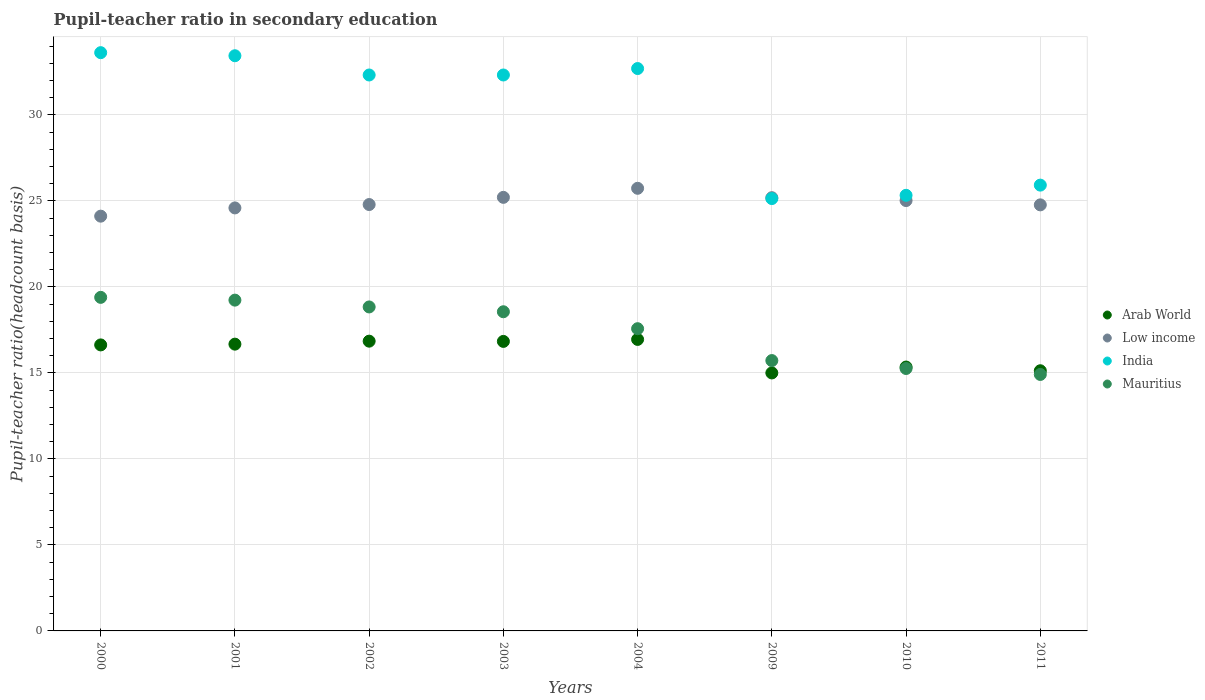How many different coloured dotlines are there?
Keep it short and to the point. 4. Is the number of dotlines equal to the number of legend labels?
Your answer should be compact. Yes. What is the pupil-teacher ratio in secondary education in Arab World in 2009?
Give a very brief answer. 15. Across all years, what is the maximum pupil-teacher ratio in secondary education in Arab World?
Ensure brevity in your answer.  16.95. Across all years, what is the minimum pupil-teacher ratio in secondary education in Mauritius?
Offer a terse response. 14.91. In which year was the pupil-teacher ratio in secondary education in India maximum?
Keep it short and to the point. 2000. In which year was the pupil-teacher ratio in secondary education in Arab World minimum?
Provide a short and direct response. 2009. What is the total pupil-teacher ratio in secondary education in Mauritius in the graph?
Ensure brevity in your answer.  139.49. What is the difference between the pupil-teacher ratio in secondary education in Arab World in 2000 and that in 2001?
Offer a terse response. -0.04. What is the difference between the pupil-teacher ratio in secondary education in Mauritius in 2004 and the pupil-teacher ratio in secondary education in India in 2002?
Make the answer very short. -14.75. What is the average pupil-teacher ratio in secondary education in Mauritius per year?
Make the answer very short. 17.44. In the year 2009, what is the difference between the pupil-teacher ratio in secondary education in Low income and pupil-teacher ratio in secondary education in Arab World?
Your response must be concise. 10.19. In how many years, is the pupil-teacher ratio in secondary education in India greater than 29?
Your answer should be very brief. 5. What is the ratio of the pupil-teacher ratio in secondary education in Mauritius in 2009 to that in 2011?
Make the answer very short. 1.05. Is the difference between the pupil-teacher ratio in secondary education in Low income in 2002 and 2003 greater than the difference between the pupil-teacher ratio in secondary education in Arab World in 2002 and 2003?
Your answer should be very brief. No. What is the difference between the highest and the second highest pupil-teacher ratio in secondary education in Mauritius?
Your response must be concise. 0.16. What is the difference between the highest and the lowest pupil-teacher ratio in secondary education in Mauritius?
Ensure brevity in your answer.  4.48. In how many years, is the pupil-teacher ratio in secondary education in Arab World greater than the average pupil-teacher ratio in secondary education in Arab World taken over all years?
Your answer should be very brief. 5. Is the sum of the pupil-teacher ratio in secondary education in Arab World in 2001 and 2002 greater than the maximum pupil-teacher ratio in secondary education in India across all years?
Your answer should be compact. No. Is it the case that in every year, the sum of the pupil-teacher ratio in secondary education in Mauritius and pupil-teacher ratio in secondary education in Arab World  is greater than the sum of pupil-teacher ratio in secondary education in India and pupil-teacher ratio in secondary education in Low income?
Keep it short and to the point. No. Does the pupil-teacher ratio in secondary education in India monotonically increase over the years?
Your response must be concise. No. Is the pupil-teacher ratio in secondary education in India strictly greater than the pupil-teacher ratio in secondary education in Mauritius over the years?
Ensure brevity in your answer.  Yes. Is the pupil-teacher ratio in secondary education in Mauritius strictly less than the pupil-teacher ratio in secondary education in India over the years?
Provide a short and direct response. Yes. How many years are there in the graph?
Provide a succinct answer. 8. What is the difference between two consecutive major ticks on the Y-axis?
Ensure brevity in your answer.  5. Where does the legend appear in the graph?
Your response must be concise. Center right. How are the legend labels stacked?
Offer a very short reply. Vertical. What is the title of the graph?
Keep it short and to the point. Pupil-teacher ratio in secondary education. Does "Cyprus" appear as one of the legend labels in the graph?
Provide a short and direct response. No. What is the label or title of the X-axis?
Provide a short and direct response. Years. What is the label or title of the Y-axis?
Provide a succinct answer. Pupil-teacher ratio(headcount basis). What is the Pupil-teacher ratio(headcount basis) in Arab World in 2000?
Ensure brevity in your answer.  16.63. What is the Pupil-teacher ratio(headcount basis) of Low income in 2000?
Your answer should be very brief. 24.12. What is the Pupil-teacher ratio(headcount basis) in India in 2000?
Keep it short and to the point. 33.62. What is the Pupil-teacher ratio(headcount basis) in Mauritius in 2000?
Make the answer very short. 19.4. What is the Pupil-teacher ratio(headcount basis) of Arab World in 2001?
Provide a short and direct response. 16.67. What is the Pupil-teacher ratio(headcount basis) of Low income in 2001?
Provide a short and direct response. 24.6. What is the Pupil-teacher ratio(headcount basis) of India in 2001?
Offer a terse response. 33.44. What is the Pupil-teacher ratio(headcount basis) in Mauritius in 2001?
Ensure brevity in your answer.  19.23. What is the Pupil-teacher ratio(headcount basis) in Arab World in 2002?
Your answer should be very brief. 16.85. What is the Pupil-teacher ratio(headcount basis) in Low income in 2002?
Provide a short and direct response. 24.79. What is the Pupil-teacher ratio(headcount basis) of India in 2002?
Your response must be concise. 32.32. What is the Pupil-teacher ratio(headcount basis) of Mauritius in 2002?
Provide a short and direct response. 18.84. What is the Pupil-teacher ratio(headcount basis) of Arab World in 2003?
Ensure brevity in your answer.  16.83. What is the Pupil-teacher ratio(headcount basis) of Low income in 2003?
Offer a terse response. 25.21. What is the Pupil-teacher ratio(headcount basis) of India in 2003?
Your response must be concise. 32.32. What is the Pupil-teacher ratio(headcount basis) in Mauritius in 2003?
Offer a very short reply. 18.56. What is the Pupil-teacher ratio(headcount basis) in Arab World in 2004?
Provide a short and direct response. 16.95. What is the Pupil-teacher ratio(headcount basis) in Low income in 2004?
Provide a succinct answer. 25.74. What is the Pupil-teacher ratio(headcount basis) in India in 2004?
Your answer should be compact. 32.7. What is the Pupil-teacher ratio(headcount basis) in Mauritius in 2004?
Offer a very short reply. 17.57. What is the Pupil-teacher ratio(headcount basis) in Arab World in 2009?
Offer a very short reply. 15. What is the Pupil-teacher ratio(headcount basis) of Low income in 2009?
Provide a short and direct response. 25.19. What is the Pupil-teacher ratio(headcount basis) of India in 2009?
Provide a succinct answer. 25.14. What is the Pupil-teacher ratio(headcount basis) in Mauritius in 2009?
Keep it short and to the point. 15.72. What is the Pupil-teacher ratio(headcount basis) of Arab World in 2010?
Give a very brief answer. 15.34. What is the Pupil-teacher ratio(headcount basis) of Low income in 2010?
Your response must be concise. 25.02. What is the Pupil-teacher ratio(headcount basis) in India in 2010?
Offer a very short reply. 25.33. What is the Pupil-teacher ratio(headcount basis) in Mauritius in 2010?
Keep it short and to the point. 15.26. What is the Pupil-teacher ratio(headcount basis) of Arab World in 2011?
Your response must be concise. 15.13. What is the Pupil-teacher ratio(headcount basis) of Low income in 2011?
Give a very brief answer. 24.77. What is the Pupil-teacher ratio(headcount basis) of India in 2011?
Give a very brief answer. 25.92. What is the Pupil-teacher ratio(headcount basis) in Mauritius in 2011?
Provide a succinct answer. 14.91. Across all years, what is the maximum Pupil-teacher ratio(headcount basis) of Arab World?
Give a very brief answer. 16.95. Across all years, what is the maximum Pupil-teacher ratio(headcount basis) of Low income?
Offer a terse response. 25.74. Across all years, what is the maximum Pupil-teacher ratio(headcount basis) in India?
Provide a succinct answer. 33.62. Across all years, what is the maximum Pupil-teacher ratio(headcount basis) in Mauritius?
Ensure brevity in your answer.  19.4. Across all years, what is the minimum Pupil-teacher ratio(headcount basis) of Arab World?
Give a very brief answer. 15. Across all years, what is the minimum Pupil-teacher ratio(headcount basis) of Low income?
Provide a short and direct response. 24.12. Across all years, what is the minimum Pupil-teacher ratio(headcount basis) of India?
Offer a terse response. 25.14. Across all years, what is the minimum Pupil-teacher ratio(headcount basis) in Mauritius?
Your answer should be very brief. 14.91. What is the total Pupil-teacher ratio(headcount basis) of Arab World in the graph?
Provide a succinct answer. 129.41. What is the total Pupil-teacher ratio(headcount basis) of Low income in the graph?
Offer a very short reply. 199.44. What is the total Pupil-teacher ratio(headcount basis) of India in the graph?
Ensure brevity in your answer.  240.81. What is the total Pupil-teacher ratio(headcount basis) in Mauritius in the graph?
Keep it short and to the point. 139.49. What is the difference between the Pupil-teacher ratio(headcount basis) in Arab World in 2000 and that in 2001?
Ensure brevity in your answer.  -0.04. What is the difference between the Pupil-teacher ratio(headcount basis) in Low income in 2000 and that in 2001?
Give a very brief answer. -0.48. What is the difference between the Pupil-teacher ratio(headcount basis) in India in 2000 and that in 2001?
Your answer should be compact. 0.18. What is the difference between the Pupil-teacher ratio(headcount basis) of Mauritius in 2000 and that in 2001?
Your answer should be compact. 0.16. What is the difference between the Pupil-teacher ratio(headcount basis) of Arab World in 2000 and that in 2002?
Give a very brief answer. -0.22. What is the difference between the Pupil-teacher ratio(headcount basis) of Low income in 2000 and that in 2002?
Ensure brevity in your answer.  -0.68. What is the difference between the Pupil-teacher ratio(headcount basis) in India in 2000 and that in 2002?
Make the answer very short. 1.3. What is the difference between the Pupil-teacher ratio(headcount basis) in Mauritius in 2000 and that in 2002?
Ensure brevity in your answer.  0.56. What is the difference between the Pupil-teacher ratio(headcount basis) in Arab World in 2000 and that in 2003?
Keep it short and to the point. -0.2. What is the difference between the Pupil-teacher ratio(headcount basis) of Low income in 2000 and that in 2003?
Your answer should be very brief. -1.09. What is the difference between the Pupil-teacher ratio(headcount basis) in India in 2000 and that in 2003?
Your answer should be very brief. 1.3. What is the difference between the Pupil-teacher ratio(headcount basis) in Mauritius in 2000 and that in 2003?
Offer a very short reply. 0.84. What is the difference between the Pupil-teacher ratio(headcount basis) of Arab World in 2000 and that in 2004?
Provide a short and direct response. -0.32. What is the difference between the Pupil-teacher ratio(headcount basis) in Low income in 2000 and that in 2004?
Your answer should be compact. -1.62. What is the difference between the Pupil-teacher ratio(headcount basis) in India in 2000 and that in 2004?
Keep it short and to the point. 0.92. What is the difference between the Pupil-teacher ratio(headcount basis) in Mauritius in 2000 and that in 2004?
Provide a short and direct response. 1.82. What is the difference between the Pupil-teacher ratio(headcount basis) of Arab World in 2000 and that in 2009?
Ensure brevity in your answer.  1.63. What is the difference between the Pupil-teacher ratio(headcount basis) of Low income in 2000 and that in 2009?
Your response must be concise. -1.07. What is the difference between the Pupil-teacher ratio(headcount basis) in India in 2000 and that in 2009?
Your response must be concise. 8.48. What is the difference between the Pupil-teacher ratio(headcount basis) in Mauritius in 2000 and that in 2009?
Provide a short and direct response. 3.68. What is the difference between the Pupil-teacher ratio(headcount basis) in Arab World in 2000 and that in 2010?
Provide a succinct answer. 1.29. What is the difference between the Pupil-teacher ratio(headcount basis) of Low income in 2000 and that in 2010?
Ensure brevity in your answer.  -0.91. What is the difference between the Pupil-teacher ratio(headcount basis) in India in 2000 and that in 2010?
Offer a terse response. 8.29. What is the difference between the Pupil-teacher ratio(headcount basis) in Mauritius in 2000 and that in 2010?
Your response must be concise. 4.14. What is the difference between the Pupil-teacher ratio(headcount basis) in Arab World in 2000 and that in 2011?
Provide a short and direct response. 1.5. What is the difference between the Pupil-teacher ratio(headcount basis) in Low income in 2000 and that in 2011?
Offer a very short reply. -0.66. What is the difference between the Pupil-teacher ratio(headcount basis) of India in 2000 and that in 2011?
Make the answer very short. 7.7. What is the difference between the Pupil-teacher ratio(headcount basis) in Mauritius in 2000 and that in 2011?
Make the answer very short. 4.48. What is the difference between the Pupil-teacher ratio(headcount basis) of Arab World in 2001 and that in 2002?
Keep it short and to the point. -0.17. What is the difference between the Pupil-teacher ratio(headcount basis) of Low income in 2001 and that in 2002?
Provide a short and direct response. -0.2. What is the difference between the Pupil-teacher ratio(headcount basis) in India in 2001 and that in 2002?
Make the answer very short. 1.12. What is the difference between the Pupil-teacher ratio(headcount basis) in Mauritius in 2001 and that in 2002?
Make the answer very short. 0.4. What is the difference between the Pupil-teacher ratio(headcount basis) of Arab World in 2001 and that in 2003?
Keep it short and to the point. -0.16. What is the difference between the Pupil-teacher ratio(headcount basis) of Low income in 2001 and that in 2003?
Your response must be concise. -0.61. What is the difference between the Pupil-teacher ratio(headcount basis) of India in 2001 and that in 2003?
Provide a succinct answer. 1.12. What is the difference between the Pupil-teacher ratio(headcount basis) of Mauritius in 2001 and that in 2003?
Provide a succinct answer. 0.68. What is the difference between the Pupil-teacher ratio(headcount basis) in Arab World in 2001 and that in 2004?
Your response must be concise. -0.27. What is the difference between the Pupil-teacher ratio(headcount basis) in Low income in 2001 and that in 2004?
Your response must be concise. -1.14. What is the difference between the Pupil-teacher ratio(headcount basis) of India in 2001 and that in 2004?
Ensure brevity in your answer.  0.74. What is the difference between the Pupil-teacher ratio(headcount basis) of Mauritius in 2001 and that in 2004?
Offer a very short reply. 1.66. What is the difference between the Pupil-teacher ratio(headcount basis) in Arab World in 2001 and that in 2009?
Make the answer very short. 1.67. What is the difference between the Pupil-teacher ratio(headcount basis) of Low income in 2001 and that in 2009?
Make the answer very short. -0.59. What is the difference between the Pupil-teacher ratio(headcount basis) of India in 2001 and that in 2009?
Your answer should be very brief. 8.31. What is the difference between the Pupil-teacher ratio(headcount basis) of Mauritius in 2001 and that in 2009?
Offer a terse response. 3.51. What is the difference between the Pupil-teacher ratio(headcount basis) of Arab World in 2001 and that in 2010?
Ensure brevity in your answer.  1.33. What is the difference between the Pupil-teacher ratio(headcount basis) of Low income in 2001 and that in 2010?
Make the answer very short. -0.43. What is the difference between the Pupil-teacher ratio(headcount basis) of India in 2001 and that in 2010?
Ensure brevity in your answer.  8.12. What is the difference between the Pupil-teacher ratio(headcount basis) in Mauritius in 2001 and that in 2010?
Keep it short and to the point. 3.98. What is the difference between the Pupil-teacher ratio(headcount basis) in Arab World in 2001 and that in 2011?
Provide a short and direct response. 1.55. What is the difference between the Pupil-teacher ratio(headcount basis) of Low income in 2001 and that in 2011?
Your response must be concise. -0.18. What is the difference between the Pupil-teacher ratio(headcount basis) of India in 2001 and that in 2011?
Make the answer very short. 7.52. What is the difference between the Pupil-teacher ratio(headcount basis) of Mauritius in 2001 and that in 2011?
Your answer should be compact. 4.32. What is the difference between the Pupil-teacher ratio(headcount basis) in Arab World in 2002 and that in 2003?
Offer a terse response. 0.01. What is the difference between the Pupil-teacher ratio(headcount basis) of Low income in 2002 and that in 2003?
Offer a very short reply. -0.42. What is the difference between the Pupil-teacher ratio(headcount basis) of India in 2002 and that in 2003?
Your answer should be compact. -0. What is the difference between the Pupil-teacher ratio(headcount basis) of Mauritius in 2002 and that in 2003?
Your answer should be very brief. 0.28. What is the difference between the Pupil-teacher ratio(headcount basis) of Arab World in 2002 and that in 2004?
Offer a very short reply. -0.1. What is the difference between the Pupil-teacher ratio(headcount basis) of Low income in 2002 and that in 2004?
Provide a short and direct response. -0.94. What is the difference between the Pupil-teacher ratio(headcount basis) of India in 2002 and that in 2004?
Your answer should be very brief. -0.38. What is the difference between the Pupil-teacher ratio(headcount basis) in Mauritius in 2002 and that in 2004?
Make the answer very short. 1.26. What is the difference between the Pupil-teacher ratio(headcount basis) of Arab World in 2002 and that in 2009?
Make the answer very short. 1.85. What is the difference between the Pupil-teacher ratio(headcount basis) in Low income in 2002 and that in 2009?
Provide a short and direct response. -0.4. What is the difference between the Pupil-teacher ratio(headcount basis) in India in 2002 and that in 2009?
Offer a terse response. 7.19. What is the difference between the Pupil-teacher ratio(headcount basis) of Mauritius in 2002 and that in 2009?
Your response must be concise. 3.12. What is the difference between the Pupil-teacher ratio(headcount basis) in Arab World in 2002 and that in 2010?
Your answer should be compact. 1.51. What is the difference between the Pupil-teacher ratio(headcount basis) of Low income in 2002 and that in 2010?
Make the answer very short. -0.23. What is the difference between the Pupil-teacher ratio(headcount basis) in India in 2002 and that in 2010?
Make the answer very short. 7. What is the difference between the Pupil-teacher ratio(headcount basis) of Mauritius in 2002 and that in 2010?
Offer a terse response. 3.58. What is the difference between the Pupil-teacher ratio(headcount basis) in Arab World in 2002 and that in 2011?
Offer a terse response. 1.72. What is the difference between the Pupil-teacher ratio(headcount basis) in Low income in 2002 and that in 2011?
Give a very brief answer. 0.02. What is the difference between the Pupil-teacher ratio(headcount basis) of India in 2002 and that in 2011?
Keep it short and to the point. 6.4. What is the difference between the Pupil-teacher ratio(headcount basis) of Mauritius in 2002 and that in 2011?
Make the answer very short. 3.93. What is the difference between the Pupil-teacher ratio(headcount basis) in Arab World in 2003 and that in 2004?
Your answer should be compact. -0.12. What is the difference between the Pupil-teacher ratio(headcount basis) of Low income in 2003 and that in 2004?
Your response must be concise. -0.53. What is the difference between the Pupil-teacher ratio(headcount basis) of India in 2003 and that in 2004?
Ensure brevity in your answer.  -0.38. What is the difference between the Pupil-teacher ratio(headcount basis) of Mauritius in 2003 and that in 2004?
Your response must be concise. 0.98. What is the difference between the Pupil-teacher ratio(headcount basis) in Arab World in 2003 and that in 2009?
Offer a terse response. 1.83. What is the difference between the Pupil-teacher ratio(headcount basis) of Low income in 2003 and that in 2009?
Your response must be concise. 0.02. What is the difference between the Pupil-teacher ratio(headcount basis) of India in 2003 and that in 2009?
Your response must be concise. 7.19. What is the difference between the Pupil-teacher ratio(headcount basis) of Mauritius in 2003 and that in 2009?
Provide a short and direct response. 2.84. What is the difference between the Pupil-teacher ratio(headcount basis) in Arab World in 2003 and that in 2010?
Provide a short and direct response. 1.49. What is the difference between the Pupil-teacher ratio(headcount basis) of Low income in 2003 and that in 2010?
Your answer should be very brief. 0.19. What is the difference between the Pupil-teacher ratio(headcount basis) in India in 2003 and that in 2010?
Your answer should be very brief. 7. What is the difference between the Pupil-teacher ratio(headcount basis) in Mauritius in 2003 and that in 2010?
Your answer should be very brief. 3.3. What is the difference between the Pupil-teacher ratio(headcount basis) in Arab World in 2003 and that in 2011?
Provide a succinct answer. 1.71. What is the difference between the Pupil-teacher ratio(headcount basis) in Low income in 2003 and that in 2011?
Offer a very short reply. 0.44. What is the difference between the Pupil-teacher ratio(headcount basis) in India in 2003 and that in 2011?
Offer a very short reply. 6.4. What is the difference between the Pupil-teacher ratio(headcount basis) of Mauritius in 2003 and that in 2011?
Provide a succinct answer. 3.65. What is the difference between the Pupil-teacher ratio(headcount basis) in Arab World in 2004 and that in 2009?
Ensure brevity in your answer.  1.95. What is the difference between the Pupil-teacher ratio(headcount basis) of Low income in 2004 and that in 2009?
Keep it short and to the point. 0.55. What is the difference between the Pupil-teacher ratio(headcount basis) in India in 2004 and that in 2009?
Your response must be concise. 7.56. What is the difference between the Pupil-teacher ratio(headcount basis) in Mauritius in 2004 and that in 2009?
Provide a succinct answer. 1.85. What is the difference between the Pupil-teacher ratio(headcount basis) in Arab World in 2004 and that in 2010?
Offer a terse response. 1.61. What is the difference between the Pupil-teacher ratio(headcount basis) of Low income in 2004 and that in 2010?
Keep it short and to the point. 0.71. What is the difference between the Pupil-teacher ratio(headcount basis) in India in 2004 and that in 2010?
Offer a terse response. 7.37. What is the difference between the Pupil-teacher ratio(headcount basis) in Mauritius in 2004 and that in 2010?
Your answer should be very brief. 2.31. What is the difference between the Pupil-teacher ratio(headcount basis) of Arab World in 2004 and that in 2011?
Provide a succinct answer. 1.82. What is the difference between the Pupil-teacher ratio(headcount basis) of Low income in 2004 and that in 2011?
Ensure brevity in your answer.  0.96. What is the difference between the Pupil-teacher ratio(headcount basis) in India in 2004 and that in 2011?
Ensure brevity in your answer.  6.78. What is the difference between the Pupil-teacher ratio(headcount basis) in Mauritius in 2004 and that in 2011?
Your answer should be compact. 2.66. What is the difference between the Pupil-teacher ratio(headcount basis) in Arab World in 2009 and that in 2010?
Give a very brief answer. -0.34. What is the difference between the Pupil-teacher ratio(headcount basis) of Low income in 2009 and that in 2010?
Make the answer very short. 0.17. What is the difference between the Pupil-teacher ratio(headcount basis) of India in 2009 and that in 2010?
Provide a succinct answer. -0.19. What is the difference between the Pupil-teacher ratio(headcount basis) of Mauritius in 2009 and that in 2010?
Your answer should be compact. 0.46. What is the difference between the Pupil-teacher ratio(headcount basis) of Arab World in 2009 and that in 2011?
Provide a succinct answer. -0.13. What is the difference between the Pupil-teacher ratio(headcount basis) of Low income in 2009 and that in 2011?
Make the answer very short. 0.42. What is the difference between the Pupil-teacher ratio(headcount basis) in India in 2009 and that in 2011?
Your answer should be compact. -0.78. What is the difference between the Pupil-teacher ratio(headcount basis) of Mauritius in 2009 and that in 2011?
Provide a succinct answer. 0.81. What is the difference between the Pupil-teacher ratio(headcount basis) in Arab World in 2010 and that in 2011?
Your answer should be compact. 0.21. What is the difference between the Pupil-teacher ratio(headcount basis) of Low income in 2010 and that in 2011?
Give a very brief answer. 0.25. What is the difference between the Pupil-teacher ratio(headcount basis) in India in 2010 and that in 2011?
Keep it short and to the point. -0.59. What is the difference between the Pupil-teacher ratio(headcount basis) of Mauritius in 2010 and that in 2011?
Keep it short and to the point. 0.35. What is the difference between the Pupil-teacher ratio(headcount basis) in Arab World in 2000 and the Pupil-teacher ratio(headcount basis) in Low income in 2001?
Give a very brief answer. -7.97. What is the difference between the Pupil-teacher ratio(headcount basis) in Arab World in 2000 and the Pupil-teacher ratio(headcount basis) in India in 2001?
Offer a very short reply. -16.81. What is the difference between the Pupil-teacher ratio(headcount basis) in Arab World in 2000 and the Pupil-teacher ratio(headcount basis) in Mauritius in 2001?
Give a very brief answer. -2.6. What is the difference between the Pupil-teacher ratio(headcount basis) of Low income in 2000 and the Pupil-teacher ratio(headcount basis) of India in 2001?
Provide a succinct answer. -9.33. What is the difference between the Pupil-teacher ratio(headcount basis) in Low income in 2000 and the Pupil-teacher ratio(headcount basis) in Mauritius in 2001?
Provide a short and direct response. 4.88. What is the difference between the Pupil-teacher ratio(headcount basis) in India in 2000 and the Pupil-teacher ratio(headcount basis) in Mauritius in 2001?
Offer a very short reply. 14.39. What is the difference between the Pupil-teacher ratio(headcount basis) of Arab World in 2000 and the Pupil-teacher ratio(headcount basis) of Low income in 2002?
Provide a succinct answer. -8.16. What is the difference between the Pupil-teacher ratio(headcount basis) of Arab World in 2000 and the Pupil-teacher ratio(headcount basis) of India in 2002?
Your answer should be very brief. -15.69. What is the difference between the Pupil-teacher ratio(headcount basis) of Arab World in 2000 and the Pupil-teacher ratio(headcount basis) of Mauritius in 2002?
Your response must be concise. -2.21. What is the difference between the Pupil-teacher ratio(headcount basis) in Low income in 2000 and the Pupil-teacher ratio(headcount basis) in India in 2002?
Make the answer very short. -8.21. What is the difference between the Pupil-teacher ratio(headcount basis) in Low income in 2000 and the Pupil-teacher ratio(headcount basis) in Mauritius in 2002?
Provide a succinct answer. 5.28. What is the difference between the Pupil-teacher ratio(headcount basis) of India in 2000 and the Pupil-teacher ratio(headcount basis) of Mauritius in 2002?
Give a very brief answer. 14.79. What is the difference between the Pupil-teacher ratio(headcount basis) in Arab World in 2000 and the Pupil-teacher ratio(headcount basis) in Low income in 2003?
Your answer should be compact. -8.58. What is the difference between the Pupil-teacher ratio(headcount basis) in Arab World in 2000 and the Pupil-teacher ratio(headcount basis) in India in 2003?
Provide a short and direct response. -15.69. What is the difference between the Pupil-teacher ratio(headcount basis) of Arab World in 2000 and the Pupil-teacher ratio(headcount basis) of Mauritius in 2003?
Your response must be concise. -1.93. What is the difference between the Pupil-teacher ratio(headcount basis) in Low income in 2000 and the Pupil-teacher ratio(headcount basis) in India in 2003?
Provide a succinct answer. -8.21. What is the difference between the Pupil-teacher ratio(headcount basis) of Low income in 2000 and the Pupil-teacher ratio(headcount basis) of Mauritius in 2003?
Your answer should be very brief. 5.56. What is the difference between the Pupil-teacher ratio(headcount basis) of India in 2000 and the Pupil-teacher ratio(headcount basis) of Mauritius in 2003?
Your response must be concise. 15.06. What is the difference between the Pupil-teacher ratio(headcount basis) in Arab World in 2000 and the Pupil-teacher ratio(headcount basis) in Low income in 2004?
Offer a very short reply. -9.11. What is the difference between the Pupil-teacher ratio(headcount basis) in Arab World in 2000 and the Pupil-teacher ratio(headcount basis) in India in 2004?
Make the answer very short. -16.07. What is the difference between the Pupil-teacher ratio(headcount basis) of Arab World in 2000 and the Pupil-teacher ratio(headcount basis) of Mauritius in 2004?
Provide a short and direct response. -0.94. What is the difference between the Pupil-teacher ratio(headcount basis) in Low income in 2000 and the Pupil-teacher ratio(headcount basis) in India in 2004?
Provide a succinct answer. -8.58. What is the difference between the Pupil-teacher ratio(headcount basis) of Low income in 2000 and the Pupil-teacher ratio(headcount basis) of Mauritius in 2004?
Give a very brief answer. 6.54. What is the difference between the Pupil-teacher ratio(headcount basis) in India in 2000 and the Pupil-teacher ratio(headcount basis) in Mauritius in 2004?
Provide a short and direct response. 16.05. What is the difference between the Pupil-teacher ratio(headcount basis) in Arab World in 2000 and the Pupil-teacher ratio(headcount basis) in Low income in 2009?
Your response must be concise. -8.56. What is the difference between the Pupil-teacher ratio(headcount basis) in Arab World in 2000 and the Pupil-teacher ratio(headcount basis) in India in 2009?
Offer a terse response. -8.51. What is the difference between the Pupil-teacher ratio(headcount basis) in Arab World in 2000 and the Pupil-teacher ratio(headcount basis) in Mauritius in 2009?
Your answer should be very brief. 0.91. What is the difference between the Pupil-teacher ratio(headcount basis) of Low income in 2000 and the Pupil-teacher ratio(headcount basis) of India in 2009?
Provide a short and direct response. -1.02. What is the difference between the Pupil-teacher ratio(headcount basis) in Low income in 2000 and the Pupil-teacher ratio(headcount basis) in Mauritius in 2009?
Offer a very short reply. 8.4. What is the difference between the Pupil-teacher ratio(headcount basis) in India in 2000 and the Pupil-teacher ratio(headcount basis) in Mauritius in 2009?
Keep it short and to the point. 17.9. What is the difference between the Pupil-teacher ratio(headcount basis) in Arab World in 2000 and the Pupil-teacher ratio(headcount basis) in Low income in 2010?
Offer a terse response. -8.39. What is the difference between the Pupil-teacher ratio(headcount basis) in Arab World in 2000 and the Pupil-teacher ratio(headcount basis) in India in 2010?
Offer a very short reply. -8.7. What is the difference between the Pupil-teacher ratio(headcount basis) of Arab World in 2000 and the Pupil-teacher ratio(headcount basis) of Mauritius in 2010?
Ensure brevity in your answer.  1.37. What is the difference between the Pupil-teacher ratio(headcount basis) of Low income in 2000 and the Pupil-teacher ratio(headcount basis) of India in 2010?
Keep it short and to the point. -1.21. What is the difference between the Pupil-teacher ratio(headcount basis) in Low income in 2000 and the Pupil-teacher ratio(headcount basis) in Mauritius in 2010?
Offer a very short reply. 8.86. What is the difference between the Pupil-teacher ratio(headcount basis) in India in 2000 and the Pupil-teacher ratio(headcount basis) in Mauritius in 2010?
Ensure brevity in your answer.  18.36. What is the difference between the Pupil-teacher ratio(headcount basis) of Arab World in 2000 and the Pupil-teacher ratio(headcount basis) of Low income in 2011?
Give a very brief answer. -8.14. What is the difference between the Pupil-teacher ratio(headcount basis) in Arab World in 2000 and the Pupil-teacher ratio(headcount basis) in India in 2011?
Make the answer very short. -9.29. What is the difference between the Pupil-teacher ratio(headcount basis) in Arab World in 2000 and the Pupil-teacher ratio(headcount basis) in Mauritius in 2011?
Your answer should be very brief. 1.72. What is the difference between the Pupil-teacher ratio(headcount basis) in Low income in 2000 and the Pupil-teacher ratio(headcount basis) in India in 2011?
Provide a succinct answer. -1.8. What is the difference between the Pupil-teacher ratio(headcount basis) in Low income in 2000 and the Pupil-teacher ratio(headcount basis) in Mauritius in 2011?
Your answer should be compact. 9.2. What is the difference between the Pupil-teacher ratio(headcount basis) in India in 2000 and the Pupil-teacher ratio(headcount basis) in Mauritius in 2011?
Your answer should be compact. 18.71. What is the difference between the Pupil-teacher ratio(headcount basis) in Arab World in 2001 and the Pupil-teacher ratio(headcount basis) in Low income in 2002?
Provide a short and direct response. -8.12. What is the difference between the Pupil-teacher ratio(headcount basis) in Arab World in 2001 and the Pupil-teacher ratio(headcount basis) in India in 2002?
Give a very brief answer. -15.65. What is the difference between the Pupil-teacher ratio(headcount basis) in Arab World in 2001 and the Pupil-teacher ratio(headcount basis) in Mauritius in 2002?
Keep it short and to the point. -2.16. What is the difference between the Pupil-teacher ratio(headcount basis) of Low income in 2001 and the Pupil-teacher ratio(headcount basis) of India in 2002?
Offer a terse response. -7.73. What is the difference between the Pupil-teacher ratio(headcount basis) of Low income in 2001 and the Pupil-teacher ratio(headcount basis) of Mauritius in 2002?
Your answer should be compact. 5.76. What is the difference between the Pupil-teacher ratio(headcount basis) of India in 2001 and the Pupil-teacher ratio(headcount basis) of Mauritius in 2002?
Offer a very short reply. 14.61. What is the difference between the Pupil-teacher ratio(headcount basis) of Arab World in 2001 and the Pupil-teacher ratio(headcount basis) of Low income in 2003?
Your answer should be very brief. -8.54. What is the difference between the Pupil-teacher ratio(headcount basis) of Arab World in 2001 and the Pupil-teacher ratio(headcount basis) of India in 2003?
Provide a succinct answer. -15.65. What is the difference between the Pupil-teacher ratio(headcount basis) of Arab World in 2001 and the Pupil-teacher ratio(headcount basis) of Mauritius in 2003?
Ensure brevity in your answer.  -1.88. What is the difference between the Pupil-teacher ratio(headcount basis) of Low income in 2001 and the Pupil-teacher ratio(headcount basis) of India in 2003?
Provide a short and direct response. -7.73. What is the difference between the Pupil-teacher ratio(headcount basis) in Low income in 2001 and the Pupil-teacher ratio(headcount basis) in Mauritius in 2003?
Your response must be concise. 6.04. What is the difference between the Pupil-teacher ratio(headcount basis) in India in 2001 and the Pupil-teacher ratio(headcount basis) in Mauritius in 2003?
Offer a very short reply. 14.89. What is the difference between the Pupil-teacher ratio(headcount basis) of Arab World in 2001 and the Pupil-teacher ratio(headcount basis) of Low income in 2004?
Provide a short and direct response. -9.06. What is the difference between the Pupil-teacher ratio(headcount basis) in Arab World in 2001 and the Pupil-teacher ratio(headcount basis) in India in 2004?
Ensure brevity in your answer.  -16.03. What is the difference between the Pupil-teacher ratio(headcount basis) in Arab World in 2001 and the Pupil-teacher ratio(headcount basis) in Mauritius in 2004?
Give a very brief answer. -0.9. What is the difference between the Pupil-teacher ratio(headcount basis) in Low income in 2001 and the Pupil-teacher ratio(headcount basis) in India in 2004?
Make the answer very short. -8.1. What is the difference between the Pupil-teacher ratio(headcount basis) in Low income in 2001 and the Pupil-teacher ratio(headcount basis) in Mauritius in 2004?
Provide a short and direct response. 7.02. What is the difference between the Pupil-teacher ratio(headcount basis) of India in 2001 and the Pupil-teacher ratio(headcount basis) of Mauritius in 2004?
Provide a succinct answer. 15.87. What is the difference between the Pupil-teacher ratio(headcount basis) of Arab World in 2001 and the Pupil-teacher ratio(headcount basis) of Low income in 2009?
Ensure brevity in your answer.  -8.52. What is the difference between the Pupil-teacher ratio(headcount basis) of Arab World in 2001 and the Pupil-teacher ratio(headcount basis) of India in 2009?
Offer a very short reply. -8.46. What is the difference between the Pupil-teacher ratio(headcount basis) of Arab World in 2001 and the Pupil-teacher ratio(headcount basis) of Mauritius in 2009?
Keep it short and to the point. 0.96. What is the difference between the Pupil-teacher ratio(headcount basis) in Low income in 2001 and the Pupil-teacher ratio(headcount basis) in India in 2009?
Keep it short and to the point. -0.54. What is the difference between the Pupil-teacher ratio(headcount basis) in Low income in 2001 and the Pupil-teacher ratio(headcount basis) in Mauritius in 2009?
Provide a short and direct response. 8.88. What is the difference between the Pupil-teacher ratio(headcount basis) of India in 2001 and the Pupil-teacher ratio(headcount basis) of Mauritius in 2009?
Offer a very short reply. 17.73. What is the difference between the Pupil-teacher ratio(headcount basis) in Arab World in 2001 and the Pupil-teacher ratio(headcount basis) in Low income in 2010?
Give a very brief answer. -8.35. What is the difference between the Pupil-teacher ratio(headcount basis) in Arab World in 2001 and the Pupil-teacher ratio(headcount basis) in India in 2010?
Keep it short and to the point. -8.65. What is the difference between the Pupil-teacher ratio(headcount basis) in Arab World in 2001 and the Pupil-teacher ratio(headcount basis) in Mauritius in 2010?
Your answer should be very brief. 1.42. What is the difference between the Pupil-teacher ratio(headcount basis) in Low income in 2001 and the Pupil-teacher ratio(headcount basis) in India in 2010?
Keep it short and to the point. -0.73. What is the difference between the Pupil-teacher ratio(headcount basis) in Low income in 2001 and the Pupil-teacher ratio(headcount basis) in Mauritius in 2010?
Provide a succinct answer. 9.34. What is the difference between the Pupil-teacher ratio(headcount basis) in India in 2001 and the Pupil-teacher ratio(headcount basis) in Mauritius in 2010?
Provide a short and direct response. 18.19. What is the difference between the Pupil-teacher ratio(headcount basis) in Arab World in 2001 and the Pupil-teacher ratio(headcount basis) in Low income in 2011?
Ensure brevity in your answer.  -8.1. What is the difference between the Pupil-teacher ratio(headcount basis) in Arab World in 2001 and the Pupil-teacher ratio(headcount basis) in India in 2011?
Make the answer very short. -9.25. What is the difference between the Pupil-teacher ratio(headcount basis) in Arab World in 2001 and the Pupil-teacher ratio(headcount basis) in Mauritius in 2011?
Keep it short and to the point. 1.76. What is the difference between the Pupil-teacher ratio(headcount basis) in Low income in 2001 and the Pupil-teacher ratio(headcount basis) in India in 2011?
Keep it short and to the point. -1.33. What is the difference between the Pupil-teacher ratio(headcount basis) of Low income in 2001 and the Pupil-teacher ratio(headcount basis) of Mauritius in 2011?
Offer a very short reply. 9.68. What is the difference between the Pupil-teacher ratio(headcount basis) in India in 2001 and the Pupil-teacher ratio(headcount basis) in Mauritius in 2011?
Ensure brevity in your answer.  18.53. What is the difference between the Pupil-teacher ratio(headcount basis) of Arab World in 2002 and the Pupil-teacher ratio(headcount basis) of Low income in 2003?
Keep it short and to the point. -8.36. What is the difference between the Pupil-teacher ratio(headcount basis) in Arab World in 2002 and the Pupil-teacher ratio(headcount basis) in India in 2003?
Ensure brevity in your answer.  -15.48. What is the difference between the Pupil-teacher ratio(headcount basis) in Arab World in 2002 and the Pupil-teacher ratio(headcount basis) in Mauritius in 2003?
Ensure brevity in your answer.  -1.71. What is the difference between the Pupil-teacher ratio(headcount basis) in Low income in 2002 and the Pupil-teacher ratio(headcount basis) in India in 2003?
Your answer should be very brief. -7.53. What is the difference between the Pupil-teacher ratio(headcount basis) of Low income in 2002 and the Pupil-teacher ratio(headcount basis) of Mauritius in 2003?
Offer a terse response. 6.23. What is the difference between the Pupil-teacher ratio(headcount basis) of India in 2002 and the Pupil-teacher ratio(headcount basis) of Mauritius in 2003?
Offer a terse response. 13.77. What is the difference between the Pupil-teacher ratio(headcount basis) of Arab World in 2002 and the Pupil-teacher ratio(headcount basis) of Low income in 2004?
Your answer should be compact. -8.89. What is the difference between the Pupil-teacher ratio(headcount basis) in Arab World in 2002 and the Pupil-teacher ratio(headcount basis) in India in 2004?
Provide a short and direct response. -15.85. What is the difference between the Pupil-teacher ratio(headcount basis) of Arab World in 2002 and the Pupil-teacher ratio(headcount basis) of Mauritius in 2004?
Keep it short and to the point. -0.73. What is the difference between the Pupil-teacher ratio(headcount basis) of Low income in 2002 and the Pupil-teacher ratio(headcount basis) of India in 2004?
Give a very brief answer. -7.91. What is the difference between the Pupil-teacher ratio(headcount basis) in Low income in 2002 and the Pupil-teacher ratio(headcount basis) in Mauritius in 2004?
Offer a very short reply. 7.22. What is the difference between the Pupil-teacher ratio(headcount basis) of India in 2002 and the Pupil-teacher ratio(headcount basis) of Mauritius in 2004?
Provide a short and direct response. 14.75. What is the difference between the Pupil-teacher ratio(headcount basis) in Arab World in 2002 and the Pupil-teacher ratio(headcount basis) in Low income in 2009?
Offer a terse response. -8.34. What is the difference between the Pupil-teacher ratio(headcount basis) of Arab World in 2002 and the Pupil-teacher ratio(headcount basis) of India in 2009?
Your answer should be compact. -8.29. What is the difference between the Pupil-teacher ratio(headcount basis) in Arab World in 2002 and the Pupil-teacher ratio(headcount basis) in Mauritius in 2009?
Give a very brief answer. 1.13. What is the difference between the Pupil-teacher ratio(headcount basis) of Low income in 2002 and the Pupil-teacher ratio(headcount basis) of India in 2009?
Your response must be concise. -0.35. What is the difference between the Pupil-teacher ratio(headcount basis) of Low income in 2002 and the Pupil-teacher ratio(headcount basis) of Mauritius in 2009?
Provide a succinct answer. 9.07. What is the difference between the Pupil-teacher ratio(headcount basis) in India in 2002 and the Pupil-teacher ratio(headcount basis) in Mauritius in 2009?
Offer a very short reply. 16.61. What is the difference between the Pupil-teacher ratio(headcount basis) in Arab World in 2002 and the Pupil-teacher ratio(headcount basis) in Low income in 2010?
Make the answer very short. -8.18. What is the difference between the Pupil-teacher ratio(headcount basis) in Arab World in 2002 and the Pupil-teacher ratio(headcount basis) in India in 2010?
Provide a short and direct response. -8.48. What is the difference between the Pupil-teacher ratio(headcount basis) of Arab World in 2002 and the Pupil-teacher ratio(headcount basis) of Mauritius in 2010?
Offer a terse response. 1.59. What is the difference between the Pupil-teacher ratio(headcount basis) of Low income in 2002 and the Pupil-teacher ratio(headcount basis) of India in 2010?
Offer a very short reply. -0.54. What is the difference between the Pupil-teacher ratio(headcount basis) of Low income in 2002 and the Pupil-teacher ratio(headcount basis) of Mauritius in 2010?
Provide a short and direct response. 9.53. What is the difference between the Pupil-teacher ratio(headcount basis) of India in 2002 and the Pupil-teacher ratio(headcount basis) of Mauritius in 2010?
Keep it short and to the point. 17.07. What is the difference between the Pupil-teacher ratio(headcount basis) of Arab World in 2002 and the Pupil-teacher ratio(headcount basis) of Low income in 2011?
Offer a very short reply. -7.92. What is the difference between the Pupil-teacher ratio(headcount basis) in Arab World in 2002 and the Pupil-teacher ratio(headcount basis) in India in 2011?
Your answer should be very brief. -9.07. What is the difference between the Pupil-teacher ratio(headcount basis) of Arab World in 2002 and the Pupil-teacher ratio(headcount basis) of Mauritius in 2011?
Provide a short and direct response. 1.94. What is the difference between the Pupil-teacher ratio(headcount basis) in Low income in 2002 and the Pupil-teacher ratio(headcount basis) in India in 2011?
Make the answer very short. -1.13. What is the difference between the Pupil-teacher ratio(headcount basis) of Low income in 2002 and the Pupil-teacher ratio(headcount basis) of Mauritius in 2011?
Provide a succinct answer. 9.88. What is the difference between the Pupil-teacher ratio(headcount basis) of India in 2002 and the Pupil-teacher ratio(headcount basis) of Mauritius in 2011?
Provide a short and direct response. 17.41. What is the difference between the Pupil-teacher ratio(headcount basis) in Arab World in 2003 and the Pupil-teacher ratio(headcount basis) in Low income in 2004?
Your answer should be very brief. -8.9. What is the difference between the Pupil-teacher ratio(headcount basis) in Arab World in 2003 and the Pupil-teacher ratio(headcount basis) in India in 2004?
Give a very brief answer. -15.87. What is the difference between the Pupil-teacher ratio(headcount basis) in Arab World in 2003 and the Pupil-teacher ratio(headcount basis) in Mauritius in 2004?
Your answer should be very brief. -0.74. What is the difference between the Pupil-teacher ratio(headcount basis) of Low income in 2003 and the Pupil-teacher ratio(headcount basis) of India in 2004?
Keep it short and to the point. -7.49. What is the difference between the Pupil-teacher ratio(headcount basis) of Low income in 2003 and the Pupil-teacher ratio(headcount basis) of Mauritius in 2004?
Ensure brevity in your answer.  7.64. What is the difference between the Pupil-teacher ratio(headcount basis) in India in 2003 and the Pupil-teacher ratio(headcount basis) in Mauritius in 2004?
Offer a terse response. 14.75. What is the difference between the Pupil-teacher ratio(headcount basis) of Arab World in 2003 and the Pupil-teacher ratio(headcount basis) of Low income in 2009?
Provide a succinct answer. -8.36. What is the difference between the Pupil-teacher ratio(headcount basis) in Arab World in 2003 and the Pupil-teacher ratio(headcount basis) in India in 2009?
Your answer should be compact. -8.31. What is the difference between the Pupil-teacher ratio(headcount basis) of Arab World in 2003 and the Pupil-teacher ratio(headcount basis) of Mauritius in 2009?
Make the answer very short. 1.11. What is the difference between the Pupil-teacher ratio(headcount basis) of Low income in 2003 and the Pupil-teacher ratio(headcount basis) of India in 2009?
Provide a short and direct response. 0.07. What is the difference between the Pupil-teacher ratio(headcount basis) in Low income in 2003 and the Pupil-teacher ratio(headcount basis) in Mauritius in 2009?
Your answer should be very brief. 9.49. What is the difference between the Pupil-teacher ratio(headcount basis) in India in 2003 and the Pupil-teacher ratio(headcount basis) in Mauritius in 2009?
Provide a short and direct response. 16.61. What is the difference between the Pupil-teacher ratio(headcount basis) in Arab World in 2003 and the Pupil-teacher ratio(headcount basis) in Low income in 2010?
Offer a very short reply. -8.19. What is the difference between the Pupil-teacher ratio(headcount basis) in Arab World in 2003 and the Pupil-teacher ratio(headcount basis) in India in 2010?
Keep it short and to the point. -8.49. What is the difference between the Pupil-teacher ratio(headcount basis) in Arab World in 2003 and the Pupil-teacher ratio(headcount basis) in Mauritius in 2010?
Give a very brief answer. 1.57. What is the difference between the Pupil-teacher ratio(headcount basis) in Low income in 2003 and the Pupil-teacher ratio(headcount basis) in India in 2010?
Offer a terse response. -0.12. What is the difference between the Pupil-teacher ratio(headcount basis) of Low income in 2003 and the Pupil-teacher ratio(headcount basis) of Mauritius in 2010?
Your response must be concise. 9.95. What is the difference between the Pupil-teacher ratio(headcount basis) of India in 2003 and the Pupil-teacher ratio(headcount basis) of Mauritius in 2010?
Provide a succinct answer. 17.07. What is the difference between the Pupil-teacher ratio(headcount basis) in Arab World in 2003 and the Pupil-teacher ratio(headcount basis) in Low income in 2011?
Ensure brevity in your answer.  -7.94. What is the difference between the Pupil-teacher ratio(headcount basis) in Arab World in 2003 and the Pupil-teacher ratio(headcount basis) in India in 2011?
Your answer should be compact. -9.09. What is the difference between the Pupil-teacher ratio(headcount basis) of Arab World in 2003 and the Pupil-teacher ratio(headcount basis) of Mauritius in 2011?
Your answer should be very brief. 1.92. What is the difference between the Pupil-teacher ratio(headcount basis) in Low income in 2003 and the Pupil-teacher ratio(headcount basis) in India in 2011?
Offer a terse response. -0.71. What is the difference between the Pupil-teacher ratio(headcount basis) in Low income in 2003 and the Pupil-teacher ratio(headcount basis) in Mauritius in 2011?
Ensure brevity in your answer.  10.3. What is the difference between the Pupil-teacher ratio(headcount basis) in India in 2003 and the Pupil-teacher ratio(headcount basis) in Mauritius in 2011?
Your answer should be compact. 17.41. What is the difference between the Pupil-teacher ratio(headcount basis) of Arab World in 2004 and the Pupil-teacher ratio(headcount basis) of Low income in 2009?
Provide a succinct answer. -8.24. What is the difference between the Pupil-teacher ratio(headcount basis) of Arab World in 2004 and the Pupil-teacher ratio(headcount basis) of India in 2009?
Your response must be concise. -8.19. What is the difference between the Pupil-teacher ratio(headcount basis) of Arab World in 2004 and the Pupil-teacher ratio(headcount basis) of Mauritius in 2009?
Ensure brevity in your answer.  1.23. What is the difference between the Pupil-teacher ratio(headcount basis) of Low income in 2004 and the Pupil-teacher ratio(headcount basis) of India in 2009?
Offer a very short reply. 0.6. What is the difference between the Pupil-teacher ratio(headcount basis) in Low income in 2004 and the Pupil-teacher ratio(headcount basis) in Mauritius in 2009?
Keep it short and to the point. 10.02. What is the difference between the Pupil-teacher ratio(headcount basis) in India in 2004 and the Pupil-teacher ratio(headcount basis) in Mauritius in 2009?
Provide a short and direct response. 16.98. What is the difference between the Pupil-teacher ratio(headcount basis) of Arab World in 2004 and the Pupil-teacher ratio(headcount basis) of Low income in 2010?
Keep it short and to the point. -8.07. What is the difference between the Pupil-teacher ratio(headcount basis) in Arab World in 2004 and the Pupil-teacher ratio(headcount basis) in India in 2010?
Give a very brief answer. -8.38. What is the difference between the Pupil-teacher ratio(headcount basis) of Arab World in 2004 and the Pupil-teacher ratio(headcount basis) of Mauritius in 2010?
Ensure brevity in your answer.  1.69. What is the difference between the Pupil-teacher ratio(headcount basis) in Low income in 2004 and the Pupil-teacher ratio(headcount basis) in India in 2010?
Your response must be concise. 0.41. What is the difference between the Pupil-teacher ratio(headcount basis) of Low income in 2004 and the Pupil-teacher ratio(headcount basis) of Mauritius in 2010?
Offer a very short reply. 10.48. What is the difference between the Pupil-teacher ratio(headcount basis) of India in 2004 and the Pupil-teacher ratio(headcount basis) of Mauritius in 2010?
Keep it short and to the point. 17.44. What is the difference between the Pupil-teacher ratio(headcount basis) of Arab World in 2004 and the Pupil-teacher ratio(headcount basis) of Low income in 2011?
Give a very brief answer. -7.82. What is the difference between the Pupil-teacher ratio(headcount basis) in Arab World in 2004 and the Pupil-teacher ratio(headcount basis) in India in 2011?
Your answer should be very brief. -8.97. What is the difference between the Pupil-teacher ratio(headcount basis) of Arab World in 2004 and the Pupil-teacher ratio(headcount basis) of Mauritius in 2011?
Provide a succinct answer. 2.04. What is the difference between the Pupil-teacher ratio(headcount basis) of Low income in 2004 and the Pupil-teacher ratio(headcount basis) of India in 2011?
Offer a very short reply. -0.18. What is the difference between the Pupil-teacher ratio(headcount basis) of Low income in 2004 and the Pupil-teacher ratio(headcount basis) of Mauritius in 2011?
Keep it short and to the point. 10.82. What is the difference between the Pupil-teacher ratio(headcount basis) of India in 2004 and the Pupil-teacher ratio(headcount basis) of Mauritius in 2011?
Keep it short and to the point. 17.79. What is the difference between the Pupil-teacher ratio(headcount basis) of Arab World in 2009 and the Pupil-teacher ratio(headcount basis) of Low income in 2010?
Keep it short and to the point. -10.02. What is the difference between the Pupil-teacher ratio(headcount basis) in Arab World in 2009 and the Pupil-teacher ratio(headcount basis) in India in 2010?
Offer a terse response. -10.33. What is the difference between the Pupil-teacher ratio(headcount basis) of Arab World in 2009 and the Pupil-teacher ratio(headcount basis) of Mauritius in 2010?
Ensure brevity in your answer.  -0.26. What is the difference between the Pupil-teacher ratio(headcount basis) in Low income in 2009 and the Pupil-teacher ratio(headcount basis) in India in 2010?
Your answer should be compact. -0.14. What is the difference between the Pupil-teacher ratio(headcount basis) in Low income in 2009 and the Pupil-teacher ratio(headcount basis) in Mauritius in 2010?
Keep it short and to the point. 9.93. What is the difference between the Pupil-teacher ratio(headcount basis) in India in 2009 and the Pupil-teacher ratio(headcount basis) in Mauritius in 2010?
Provide a succinct answer. 9.88. What is the difference between the Pupil-teacher ratio(headcount basis) of Arab World in 2009 and the Pupil-teacher ratio(headcount basis) of Low income in 2011?
Ensure brevity in your answer.  -9.77. What is the difference between the Pupil-teacher ratio(headcount basis) of Arab World in 2009 and the Pupil-teacher ratio(headcount basis) of India in 2011?
Provide a succinct answer. -10.92. What is the difference between the Pupil-teacher ratio(headcount basis) in Arab World in 2009 and the Pupil-teacher ratio(headcount basis) in Mauritius in 2011?
Make the answer very short. 0.09. What is the difference between the Pupil-teacher ratio(headcount basis) in Low income in 2009 and the Pupil-teacher ratio(headcount basis) in India in 2011?
Keep it short and to the point. -0.73. What is the difference between the Pupil-teacher ratio(headcount basis) of Low income in 2009 and the Pupil-teacher ratio(headcount basis) of Mauritius in 2011?
Your answer should be compact. 10.28. What is the difference between the Pupil-teacher ratio(headcount basis) in India in 2009 and the Pupil-teacher ratio(headcount basis) in Mauritius in 2011?
Your answer should be very brief. 10.23. What is the difference between the Pupil-teacher ratio(headcount basis) of Arab World in 2010 and the Pupil-teacher ratio(headcount basis) of Low income in 2011?
Provide a short and direct response. -9.43. What is the difference between the Pupil-teacher ratio(headcount basis) of Arab World in 2010 and the Pupil-teacher ratio(headcount basis) of India in 2011?
Provide a short and direct response. -10.58. What is the difference between the Pupil-teacher ratio(headcount basis) of Arab World in 2010 and the Pupil-teacher ratio(headcount basis) of Mauritius in 2011?
Offer a very short reply. 0.43. What is the difference between the Pupil-teacher ratio(headcount basis) of Low income in 2010 and the Pupil-teacher ratio(headcount basis) of India in 2011?
Ensure brevity in your answer.  -0.9. What is the difference between the Pupil-teacher ratio(headcount basis) in Low income in 2010 and the Pupil-teacher ratio(headcount basis) in Mauritius in 2011?
Provide a succinct answer. 10.11. What is the difference between the Pupil-teacher ratio(headcount basis) in India in 2010 and the Pupil-teacher ratio(headcount basis) in Mauritius in 2011?
Your response must be concise. 10.42. What is the average Pupil-teacher ratio(headcount basis) in Arab World per year?
Keep it short and to the point. 16.18. What is the average Pupil-teacher ratio(headcount basis) in Low income per year?
Make the answer very short. 24.93. What is the average Pupil-teacher ratio(headcount basis) of India per year?
Your response must be concise. 30.1. What is the average Pupil-teacher ratio(headcount basis) in Mauritius per year?
Ensure brevity in your answer.  17.44. In the year 2000, what is the difference between the Pupil-teacher ratio(headcount basis) in Arab World and Pupil-teacher ratio(headcount basis) in Low income?
Offer a very short reply. -7.49. In the year 2000, what is the difference between the Pupil-teacher ratio(headcount basis) in Arab World and Pupil-teacher ratio(headcount basis) in India?
Keep it short and to the point. -16.99. In the year 2000, what is the difference between the Pupil-teacher ratio(headcount basis) of Arab World and Pupil-teacher ratio(headcount basis) of Mauritius?
Offer a terse response. -2.76. In the year 2000, what is the difference between the Pupil-teacher ratio(headcount basis) of Low income and Pupil-teacher ratio(headcount basis) of India?
Offer a very short reply. -9.51. In the year 2000, what is the difference between the Pupil-teacher ratio(headcount basis) in Low income and Pupil-teacher ratio(headcount basis) in Mauritius?
Keep it short and to the point. 4.72. In the year 2000, what is the difference between the Pupil-teacher ratio(headcount basis) in India and Pupil-teacher ratio(headcount basis) in Mauritius?
Provide a short and direct response. 14.23. In the year 2001, what is the difference between the Pupil-teacher ratio(headcount basis) of Arab World and Pupil-teacher ratio(headcount basis) of Low income?
Your response must be concise. -7.92. In the year 2001, what is the difference between the Pupil-teacher ratio(headcount basis) of Arab World and Pupil-teacher ratio(headcount basis) of India?
Your answer should be very brief. -16.77. In the year 2001, what is the difference between the Pupil-teacher ratio(headcount basis) of Arab World and Pupil-teacher ratio(headcount basis) of Mauritius?
Your response must be concise. -2.56. In the year 2001, what is the difference between the Pupil-teacher ratio(headcount basis) of Low income and Pupil-teacher ratio(headcount basis) of India?
Your answer should be compact. -8.85. In the year 2001, what is the difference between the Pupil-teacher ratio(headcount basis) of Low income and Pupil-teacher ratio(headcount basis) of Mauritius?
Your answer should be compact. 5.36. In the year 2001, what is the difference between the Pupil-teacher ratio(headcount basis) of India and Pupil-teacher ratio(headcount basis) of Mauritius?
Your answer should be compact. 14.21. In the year 2002, what is the difference between the Pupil-teacher ratio(headcount basis) of Arab World and Pupil-teacher ratio(headcount basis) of Low income?
Provide a short and direct response. -7.94. In the year 2002, what is the difference between the Pupil-teacher ratio(headcount basis) of Arab World and Pupil-teacher ratio(headcount basis) of India?
Provide a short and direct response. -15.48. In the year 2002, what is the difference between the Pupil-teacher ratio(headcount basis) in Arab World and Pupil-teacher ratio(headcount basis) in Mauritius?
Ensure brevity in your answer.  -1.99. In the year 2002, what is the difference between the Pupil-teacher ratio(headcount basis) of Low income and Pupil-teacher ratio(headcount basis) of India?
Ensure brevity in your answer.  -7.53. In the year 2002, what is the difference between the Pupil-teacher ratio(headcount basis) of Low income and Pupil-teacher ratio(headcount basis) of Mauritius?
Make the answer very short. 5.95. In the year 2002, what is the difference between the Pupil-teacher ratio(headcount basis) of India and Pupil-teacher ratio(headcount basis) of Mauritius?
Your answer should be very brief. 13.49. In the year 2003, what is the difference between the Pupil-teacher ratio(headcount basis) of Arab World and Pupil-teacher ratio(headcount basis) of Low income?
Give a very brief answer. -8.38. In the year 2003, what is the difference between the Pupil-teacher ratio(headcount basis) of Arab World and Pupil-teacher ratio(headcount basis) of India?
Provide a succinct answer. -15.49. In the year 2003, what is the difference between the Pupil-teacher ratio(headcount basis) in Arab World and Pupil-teacher ratio(headcount basis) in Mauritius?
Keep it short and to the point. -1.72. In the year 2003, what is the difference between the Pupil-teacher ratio(headcount basis) of Low income and Pupil-teacher ratio(headcount basis) of India?
Your response must be concise. -7.11. In the year 2003, what is the difference between the Pupil-teacher ratio(headcount basis) in Low income and Pupil-teacher ratio(headcount basis) in Mauritius?
Your answer should be very brief. 6.65. In the year 2003, what is the difference between the Pupil-teacher ratio(headcount basis) of India and Pupil-teacher ratio(headcount basis) of Mauritius?
Provide a short and direct response. 13.77. In the year 2004, what is the difference between the Pupil-teacher ratio(headcount basis) in Arab World and Pupil-teacher ratio(headcount basis) in Low income?
Your answer should be compact. -8.79. In the year 2004, what is the difference between the Pupil-teacher ratio(headcount basis) of Arab World and Pupil-teacher ratio(headcount basis) of India?
Provide a succinct answer. -15.75. In the year 2004, what is the difference between the Pupil-teacher ratio(headcount basis) in Arab World and Pupil-teacher ratio(headcount basis) in Mauritius?
Your answer should be very brief. -0.62. In the year 2004, what is the difference between the Pupil-teacher ratio(headcount basis) in Low income and Pupil-teacher ratio(headcount basis) in India?
Give a very brief answer. -6.96. In the year 2004, what is the difference between the Pupil-teacher ratio(headcount basis) of Low income and Pupil-teacher ratio(headcount basis) of Mauritius?
Offer a terse response. 8.16. In the year 2004, what is the difference between the Pupil-teacher ratio(headcount basis) in India and Pupil-teacher ratio(headcount basis) in Mauritius?
Ensure brevity in your answer.  15.13. In the year 2009, what is the difference between the Pupil-teacher ratio(headcount basis) in Arab World and Pupil-teacher ratio(headcount basis) in Low income?
Provide a short and direct response. -10.19. In the year 2009, what is the difference between the Pupil-teacher ratio(headcount basis) in Arab World and Pupil-teacher ratio(headcount basis) in India?
Offer a very short reply. -10.14. In the year 2009, what is the difference between the Pupil-teacher ratio(headcount basis) in Arab World and Pupil-teacher ratio(headcount basis) in Mauritius?
Give a very brief answer. -0.72. In the year 2009, what is the difference between the Pupil-teacher ratio(headcount basis) in Low income and Pupil-teacher ratio(headcount basis) in India?
Ensure brevity in your answer.  0.05. In the year 2009, what is the difference between the Pupil-teacher ratio(headcount basis) of Low income and Pupil-teacher ratio(headcount basis) of Mauritius?
Provide a short and direct response. 9.47. In the year 2009, what is the difference between the Pupil-teacher ratio(headcount basis) of India and Pupil-teacher ratio(headcount basis) of Mauritius?
Your response must be concise. 9.42. In the year 2010, what is the difference between the Pupil-teacher ratio(headcount basis) of Arab World and Pupil-teacher ratio(headcount basis) of Low income?
Ensure brevity in your answer.  -9.68. In the year 2010, what is the difference between the Pupil-teacher ratio(headcount basis) in Arab World and Pupil-teacher ratio(headcount basis) in India?
Provide a succinct answer. -9.99. In the year 2010, what is the difference between the Pupil-teacher ratio(headcount basis) of Arab World and Pupil-teacher ratio(headcount basis) of Mauritius?
Ensure brevity in your answer.  0.08. In the year 2010, what is the difference between the Pupil-teacher ratio(headcount basis) in Low income and Pupil-teacher ratio(headcount basis) in India?
Offer a very short reply. -0.3. In the year 2010, what is the difference between the Pupil-teacher ratio(headcount basis) of Low income and Pupil-teacher ratio(headcount basis) of Mauritius?
Provide a short and direct response. 9.76. In the year 2010, what is the difference between the Pupil-teacher ratio(headcount basis) in India and Pupil-teacher ratio(headcount basis) in Mauritius?
Offer a terse response. 10.07. In the year 2011, what is the difference between the Pupil-teacher ratio(headcount basis) of Arab World and Pupil-teacher ratio(headcount basis) of Low income?
Offer a terse response. -9.65. In the year 2011, what is the difference between the Pupil-teacher ratio(headcount basis) of Arab World and Pupil-teacher ratio(headcount basis) of India?
Provide a succinct answer. -10.79. In the year 2011, what is the difference between the Pupil-teacher ratio(headcount basis) of Arab World and Pupil-teacher ratio(headcount basis) of Mauritius?
Offer a terse response. 0.22. In the year 2011, what is the difference between the Pupil-teacher ratio(headcount basis) in Low income and Pupil-teacher ratio(headcount basis) in India?
Your response must be concise. -1.15. In the year 2011, what is the difference between the Pupil-teacher ratio(headcount basis) of Low income and Pupil-teacher ratio(headcount basis) of Mauritius?
Give a very brief answer. 9.86. In the year 2011, what is the difference between the Pupil-teacher ratio(headcount basis) of India and Pupil-teacher ratio(headcount basis) of Mauritius?
Offer a terse response. 11.01. What is the ratio of the Pupil-teacher ratio(headcount basis) in Arab World in 2000 to that in 2001?
Ensure brevity in your answer.  1. What is the ratio of the Pupil-teacher ratio(headcount basis) in Low income in 2000 to that in 2001?
Offer a very short reply. 0.98. What is the ratio of the Pupil-teacher ratio(headcount basis) of India in 2000 to that in 2001?
Offer a terse response. 1.01. What is the ratio of the Pupil-teacher ratio(headcount basis) in Mauritius in 2000 to that in 2001?
Make the answer very short. 1.01. What is the ratio of the Pupil-teacher ratio(headcount basis) of Arab World in 2000 to that in 2002?
Provide a short and direct response. 0.99. What is the ratio of the Pupil-teacher ratio(headcount basis) of Low income in 2000 to that in 2002?
Provide a short and direct response. 0.97. What is the ratio of the Pupil-teacher ratio(headcount basis) of India in 2000 to that in 2002?
Give a very brief answer. 1.04. What is the ratio of the Pupil-teacher ratio(headcount basis) in Mauritius in 2000 to that in 2002?
Provide a succinct answer. 1.03. What is the ratio of the Pupil-teacher ratio(headcount basis) of Arab World in 2000 to that in 2003?
Offer a terse response. 0.99. What is the ratio of the Pupil-teacher ratio(headcount basis) of Low income in 2000 to that in 2003?
Offer a very short reply. 0.96. What is the ratio of the Pupil-teacher ratio(headcount basis) of India in 2000 to that in 2003?
Provide a succinct answer. 1.04. What is the ratio of the Pupil-teacher ratio(headcount basis) of Mauritius in 2000 to that in 2003?
Your response must be concise. 1.05. What is the ratio of the Pupil-teacher ratio(headcount basis) in Arab World in 2000 to that in 2004?
Keep it short and to the point. 0.98. What is the ratio of the Pupil-teacher ratio(headcount basis) of Low income in 2000 to that in 2004?
Offer a very short reply. 0.94. What is the ratio of the Pupil-teacher ratio(headcount basis) of India in 2000 to that in 2004?
Offer a very short reply. 1.03. What is the ratio of the Pupil-teacher ratio(headcount basis) in Mauritius in 2000 to that in 2004?
Ensure brevity in your answer.  1.1. What is the ratio of the Pupil-teacher ratio(headcount basis) in Arab World in 2000 to that in 2009?
Your answer should be very brief. 1.11. What is the ratio of the Pupil-teacher ratio(headcount basis) in Low income in 2000 to that in 2009?
Your answer should be compact. 0.96. What is the ratio of the Pupil-teacher ratio(headcount basis) of India in 2000 to that in 2009?
Make the answer very short. 1.34. What is the ratio of the Pupil-teacher ratio(headcount basis) of Mauritius in 2000 to that in 2009?
Your answer should be compact. 1.23. What is the ratio of the Pupil-teacher ratio(headcount basis) of Arab World in 2000 to that in 2010?
Your answer should be compact. 1.08. What is the ratio of the Pupil-teacher ratio(headcount basis) in Low income in 2000 to that in 2010?
Offer a very short reply. 0.96. What is the ratio of the Pupil-teacher ratio(headcount basis) of India in 2000 to that in 2010?
Your response must be concise. 1.33. What is the ratio of the Pupil-teacher ratio(headcount basis) of Mauritius in 2000 to that in 2010?
Provide a succinct answer. 1.27. What is the ratio of the Pupil-teacher ratio(headcount basis) in Arab World in 2000 to that in 2011?
Give a very brief answer. 1.1. What is the ratio of the Pupil-teacher ratio(headcount basis) of Low income in 2000 to that in 2011?
Ensure brevity in your answer.  0.97. What is the ratio of the Pupil-teacher ratio(headcount basis) of India in 2000 to that in 2011?
Ensure brevity in your answer.  1.3. What is the ratio of the Pupil-teacher ratio(headcount basis) of Mauritius in 2000 to that in 2011?
Ensure brevity in your answer.  1.3. What is the ratio of the Pupil-teacher ratio(headcount basis) in India in 2001 to that in 2002?
Make the answer very short. 1.03. What is the ratio of the Pupil-teacher ratio(headcount basis) of Mauritius in 2001 to that in 2002?
Give a very brief answer. 1.02. What is the ratio of the Pupil-teacher ratio(headcount basis) of Arab World in 2001 to that in 2003?
Offer a very short reply. 0.99. What is the ratio of the Pupil-teacher ratio(headcount basis) in Low income in 2001 to that in 2003?
Ensure brevity in your answer.  0.98. What is the ratio of the Pupil-teacher ratio(headcount basis) of India in 2001 to that in 2003?
Offer a terse response. 1.03. What is the ratio of the Pupil-teacher ratio(headcount basis) in Mauritius in 2001 to that in 2003?
Your answer should be compact. 1.04. What is the ratio of the Pupil-teacher ratio(headcount basis) in Arab World in 2001 to that in 2004?
Your response must be concise. 0.98. What is the ratio of the Pupil-teacher ratio(headcount basis) in Low income in 2001 to that in 2004?
Offer a very short reply. 0.96. What is the ratio of the Pupil-teacher ratio(headcount basis) of India in 2001 to that in 2004?
Your answer should be very brief. 1.02. What is the ratio of the Pupil-teacher ratio(headcount basis) of Mauritius in 2001 to that in 2004?
Offer a very short reply. 1.09. What is the ratio of the Pupil-teacher ratio(headcount basis) in Arab World in 2001 to that in 2009?
Offer a terse response. 1.11. What is the ratio of the Pupil-teacher ratio(headcount basis) of Low income in 2001 to that in 2009?
Provide a short and direct response. 0.98. What is the ratio of the Pupil-teacher ratio(headcount basis) in India in 2001 to that in 2009?
Ensure brevity in your answer.  1.33. What is the ratio of the Pupil-teacher ratio(headcount basis) of Mauritius in 2001 to that in 2009?
Offer a terse response. 1.22. What is the ratio of the Pupil-teacher ratio(headcount basis) of Arab World in 2001 to that in 2010?
Keep it short and to the point. 1.09. What is the ratio of the Pupil-teacher ratio(headcount basis) of Low income in 2001 to that in 2010?
Provide a short and direct response. 0.98. What is the ratio of the Pupil-teacher ratio(headcount basis) in India in 2001 to that in 2010?
Make the answer very short. 1.32. What is the ratio of the Pupil-teacher ratio(headcount basis) of Mauritius in 2001 to that in 2010?
Provide a succinct answer. 1.26. What is the ratio of the Pupil-teacher ratio(headcount basis) in Arab World in 2001 to that in 2011?
Offer a very short reply. 1.1. What is the ratio of the Pupil-teacher ratio(headcount basis) in Low income in 2001 to that in 2011?
Your answer should be very brief. 0.99. What is the ratio of the Pupil-teacher ratio(headcount basis) in India in 2001 to that in 2011?
Ensure brevity in your answer.  1.29. What is the ratio of the Pupil-teacher ratio(headcount basis) in Mauritius in 2001 to that in 2011?
Keep it short and to the point. 1.29. What is the ratio of the Pupil-teacher ratio(headcount basis) of Low income in 2002 to that in 2003?
Offer a very short reply. 0.98. What is the ratio of the Pupil-teacher ratio(headcount basis) in India in 2002 to that in 2003?
Provide a succinct answer. 1. What is the ratio of the Pupil-teacher ratio(headcount basis) of Mauritius in 2002 to that in 2003?
Offer a very short reply. 1.02. What is the ratio of the Pupil-teacher ratio(headcount basis) of Arab World in 2002 to that in 2004?
Offer a very short reply. 0.99. What is the ratio of the Pupil-teacher ratio(headcount basis) of Low income in 2002 to that in 2004?
Your answer should be compact. 0.96. What is the ratio of the Pupil-teacher ratio(headcount basis) in India in 2002 to that in 2004?
Your response must be concise. 0.99. What is the ratio of the Pupil-teacher ratio(headcount basis) of Mauritius in 2002 to that in 2004?
Offer a very short reply. 1.07. What is the ratio of the Pupil-teacher ratio(headcount basis) of Arab World in 2002 to that in 2009?
Offer a terse response. 1.12. What is the ratio of the Pupil-teacher ratio(headcount basis) in Low income in 2002 to that in 2009?
Offer a very short reply. 0.98. What is the ratio of the Pupil-teacher ratio(headcount basis) of India in 2002 to that in 2009?
Your answer should be very brief. 1.29. What is the ratio of the Pupil-teacher ratio(headcount basis) in Mauritius in 2002 to that in 2009?
Offer a terse response. 1.2. What is the ratio of the Pupil-teacher ratio(headcount basis) of Arab World in 2002 to that in 2010?
Offer a terse response. 1.1. What is the ratio of the Pupil-teacher ratio(headcount basis) in India in 2002 to that in 2010?
Your response must be concise. 1.28. What is the ratio of the Pupil-teacher ratio(headcount basis) of Mauritius in 2002 to that in 2010?
Provide a short and direct response. 1.23. What is the ratio of the Pupil-teacher ratio(headcount basis) of Arab World in 2002 to that in 2011?
Keep it short and to the point. 1.11. What is the ratio of the Pupil-teacher ratio(headcount basis) of Low income in 2002 to that in 2011?
Give a very brief answer. 1. What is the ratio of the Pupil-teacher ratio(headcount basis) of India in 2002 to that in 2011?
Provide a short and direct response. 1.25. What is the ratio of the Pupil-teacher ratio(headcount basis) in Mauritius in 2002 to that in 2011?
Give a very brief answer. 1.26. What is the ratio of the Pupil-teacher ratio(headcount basis) in Low income in 2003 to that in 2004?
Offer a very short reply. 0.98. What is the ratio of the Pupil-teacher ratio(headcount basis) of Mauritius in 2003 to that in 2004?
Offer a very short reply. 1.06. What is the ratio of the Pupil-teacher ratio(headcount basis) in Arab World in 2003 to that in 2009?
Keep it short and to the point. 1.12. What is the ratio of the Pupil-teacher ratio(headcount basis) in India in 2003 to that in 2009?
Provide a succinct answer. 1.29. What is the ratio of the Pupil-teacher ratio(headcount basis) of Mauritius in 2003 to that in 2009?
Your answer should be very brief. 1.18. What is the ratio of the Pupil-teacher ratio(headcount basis) of Arab World in 2003 to that in 2010?
Offer a very short reply. 1.1. What is the ratio of the Pupil-teacher ratio(headcount basis) in Low income in 2003 to that in 2010?
Keep it short and to the point. 1.01. What is the ratio of the Pupil-teacher ratio(headcount basis) in India in 2003 to that in 2010?
Provide a succinct answer. 1.28. What is the ratio of the Pupil-teacher ratio(headcount basis) of Mauritius in 2003 to that in 2010?
Your answer should be very brief. 1.22. What is the ratio of the Pupil-teacher ratio(headcount basis) of Arab World in 2003 to that in 2011?
Offer a very short reply. 1.11. What is the ratio of the Pupil-teacher ratio(headcount basis) of Low income in 2003 to that in 2011?
Make the answer very short. 1.02. What is the ratio of the Pupil-teacher ratio(headcount basis) of India in 2003 to that in 2011?
Provide a short and direct response. 1.25. What is the ratio of the Pupil-teacher ratio(headcount basis) in Mauritius in 2003 to that in 2011?
Provide a succinct answer. 1.24. What is the ratio of the Pupil-teacher ratio(headcount basis) of Arab World in 2004 to that in 2009?
Give a very brief answer. 1.13. What is the ratio of the Pupil-teacher ratio(headcount basis) in Low income in 2004 to that in 2009?
Offer a very short reply. 1.02. What is the ratio of the Pupil-teacher ratio(headcount basis) of India in 2004 to that in 2009?
Make the answer very short. 1.3. What is the ratio of the Pupil-teacher ratio(headcount basis) of Mauritius in 2004 to that in 2009?
Make the answer very short. 1.12. What is the ratio of the Pupil-teacher ratio(headcount basis) of Arab World in 2004 to that in 2010?
Offer a very short reply. 1.1. What is the ratio of the Pupil-teacher ratio(headcount basis) in Low income in 2004 to that in 2010?
Provide a short and direct response. 1.03. What is the ratio of the Pupil-teacher ratio(headcount basis) of India in 2004 to that in 2010?
Offer a very short reply. 1.29. What is the ratio of the Pupil-teacher ratio(headcount basis) in Mauritius in 2004 to that in 2010?
Ensure brevity in your answer.  1.15. What is the ratio of the Pupil-teacher ratio(headcount basis) in Arab World in 2004 to that in 2011?
Your answer should be very brief. 1.12. What is the ratio of the Pupil-teacher ratio(headcount basis) of Low income in 2004 to that in 2011?
Keep it short and to the point. 1.04. What is the ratio of the Pupil-teacher ratio(headcount basis) of India in 2004 to that in 2011?
Give a very brief answer. 1.26. What is the ratio of the Pupil-teacher ratio(headcount basis) in Mauritius in 2004 to that in 2011?
Keep it short and to the point. 1.18. What is the ratio of the Pupil-teacher ratio(headcount basis) of Arab World in 2009 to that in 2010?
Provide a succinct answer. 0.98. What is the ratio of the Pupil-teacher ratio(headcount basis) in Low income in 2009 to that in 2010?
Your answer should be compact. 1.01. What is the ratio of the Pupil-teacher ratio(headcount basis) in Mauritius in 2009 to that in 2010?
Offer a very short reply. 1.03. What is the ratio of the Pupil-teacher ratio(headcount basis) in Low income in 2009 to that in 2011?
Your answer should be compact. 1.02. What is the ratio of the Pupil-teacher ratio(headcount basis) of India in 2009 to that in 2011?
Your answer should be very brief. 0.97. What is the ratio of the Pupil-teacher ratio(headcount basis) in Mauritius in 2009 to that in 2011?
Your answer should be very brief. 1.05. What is the ratio of the Pupil-teacher ratio(headcount basis) in Arab World in 2010 to that in 2011?
Keep it short and to the point. 1.01. What is the ratio of the Pupil-teacher ratio(headcount basis) of Low income in 2010 to that in 2011?
Give a very brief answer. 1.01. What is the ratio of the Pupil-teacher ratio(headcount basis) in India in 2010 to that in 2011?
Ensure brevity in your answer.  0.98. What is the ratio of the Pupil-teacher ratio(headcount basis) of Mauritius in 2010 to that in 2011?
Offer a terse response. 1.02. What is the difference between the highest and the second highest Pupil-teacher ratio(headcount basis) in Arab World?
Give a very brief answer. 0.1. What is the difference between the highest and the second highest Pupil-teacher ratio(headcount basis) of Low income?
Keep it short and to the point. 0.53. What is the difference between the highest and the second highest Pupil-teacher ratio(headcount basis) of India?
Your answer should be compact. 0.18. What is the difference between the highest and the second highest Pupil-teacher ratio(headcount basis) in Mauritius?
Keep it short and to the point. 0.16. What is the difference between the highest and the lowest Pupil-teacher ratio(headcount basis) in Arab World?
Ensure brevity in your answer.  1.95. What is the difference between the highest and the lowest Pupil-teacher ratio(headcount basis) of Low income?
Your response must be concise. 1.62. What is the difference between the highest and the lowest Pupil-teacher ratio(headcount basis) of India?
Ensure brevity in your answer.  8.48. What is the difference between the highest and the lowest Pupil-teacher ratio(headcount basis) of Mauritius?
Ensure brevity in your answer.  4.48. 